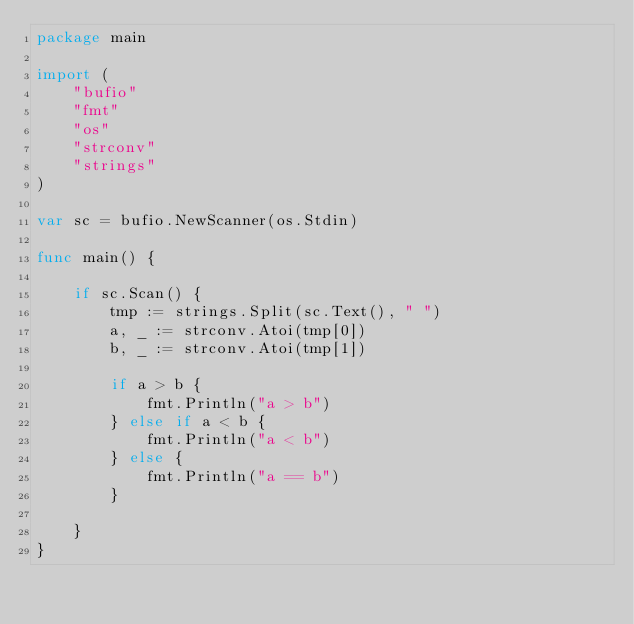<code> <loc_0><loc_0><loc_500><loc_500><_Go_>package main

import (
	"bufio"
	"fmt"
	"os"
	"strconv"
	"strings"
)

var sc = bufio.NewScanner(os.Stdin)

func main() {

	if sc.Scan() {
		tmp := strings.Split(sc.Text(), " ")
		a, _ := strconv.Atoi(tmp[0])
		b, _ := strconv.Atoi(tmp[1])

		if a > b {
			fmt.Println("a > b")
		} else if a < b {
			fmt.Println("a < b")
		} else {
			fmt.Println("a == b")
		}

	}
}

</code> 